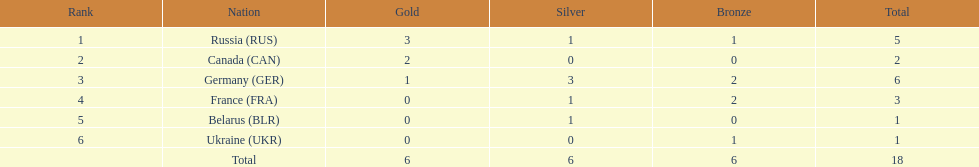What were the only 3 states to claim gold medals at the 1994 winter olympics biathlon? Russia (RUS), Canada (CAN), Germany (GER). Write the full table. {'header': ['Rank', 'Nation', 'Gold', 'Silver', 'Bronze', 'Total'], 'rows': [['1', 'Russia\xa0(RUS)', '3', '1', '1', '5'], ['2', 'Canada\xa0(CAN)', '2', '0', '0', '2'], ['3', 'Germany\xa0(GER)', '1', '3', '2', '6'], ['4', 'France\xa0(FRA)', '0', '1', '2', '3'], ['5', 'Belarus\xa0(BLR)', '0', '1', '0', '1'], ['6', 'Ukraine\xa0(UKR)', '0', '0', '1', '1'], ['', 'Total', '6', '6', '6', '18']]} 